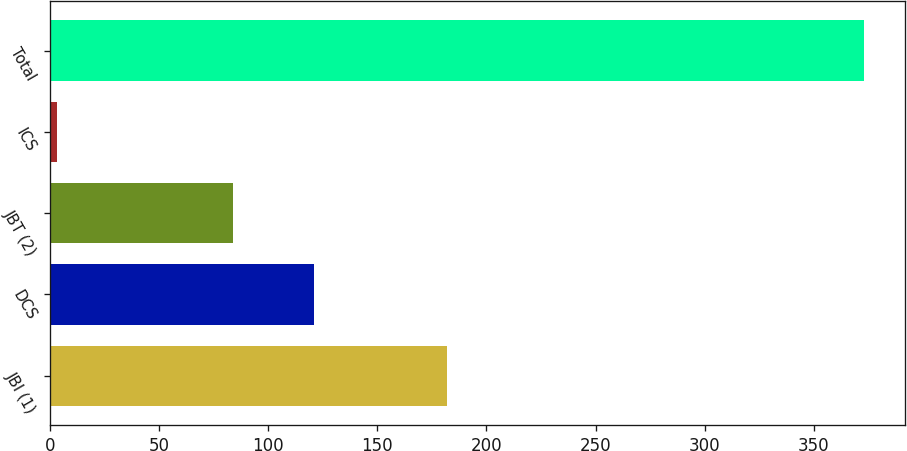<chart> <loc_0><loc_0><loc_500><loc_500><bar_chart><fcel>JBI (1)<fcel>DCS<fcel>JBT (2)<fcel>ICS<fcel>Total<nl><fcel>182<fcel>121<fcel>84<fcel>3<fcel>373<nl></chart> 